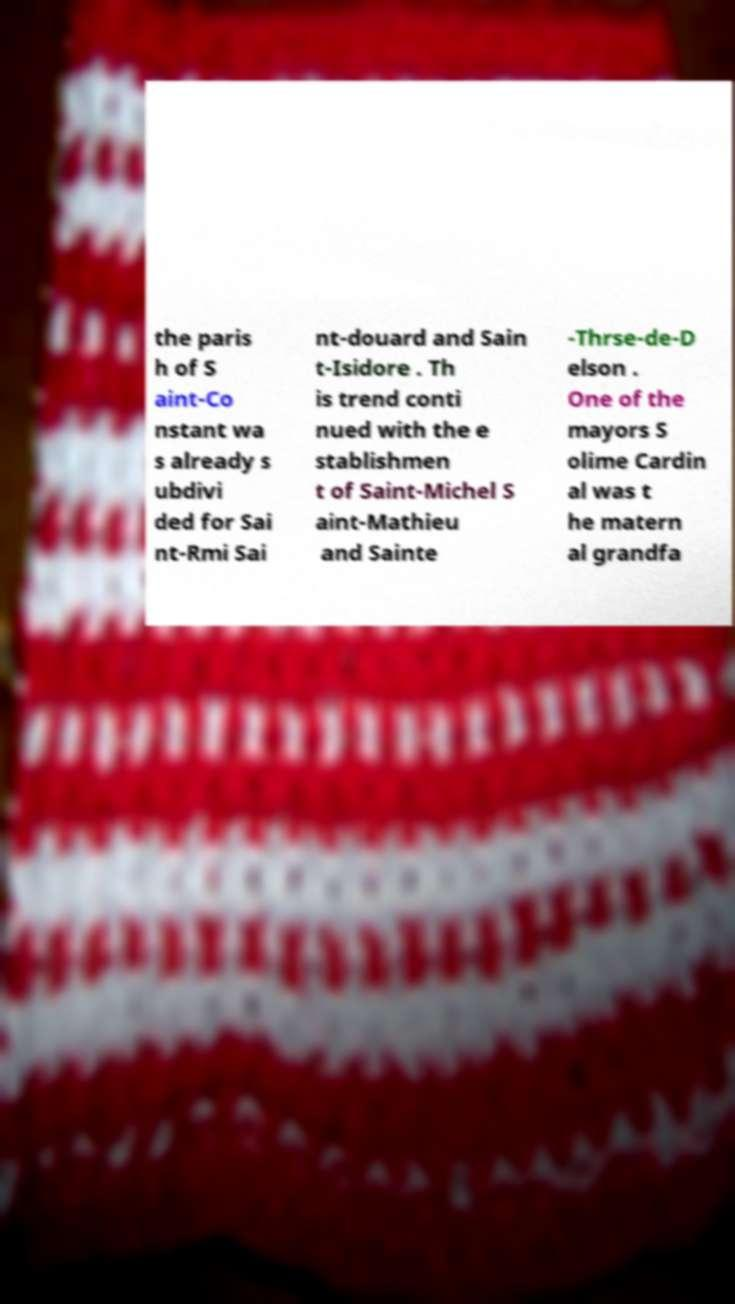Could you assist in decoding the text presented in this image and type it out clearly? the paris h of S aint-Co nstant wa s already s ubdivi ded for Sai nt-Rmi Sai nt-douard and Sain t-Isidore . Th is trend conti nued with the e stablishmen t of Saint-Michel S aint-Mathieu and Sainte -Thrse-de-D elson . One of the mayors S olime Cardin al was t he matern al grandfa 